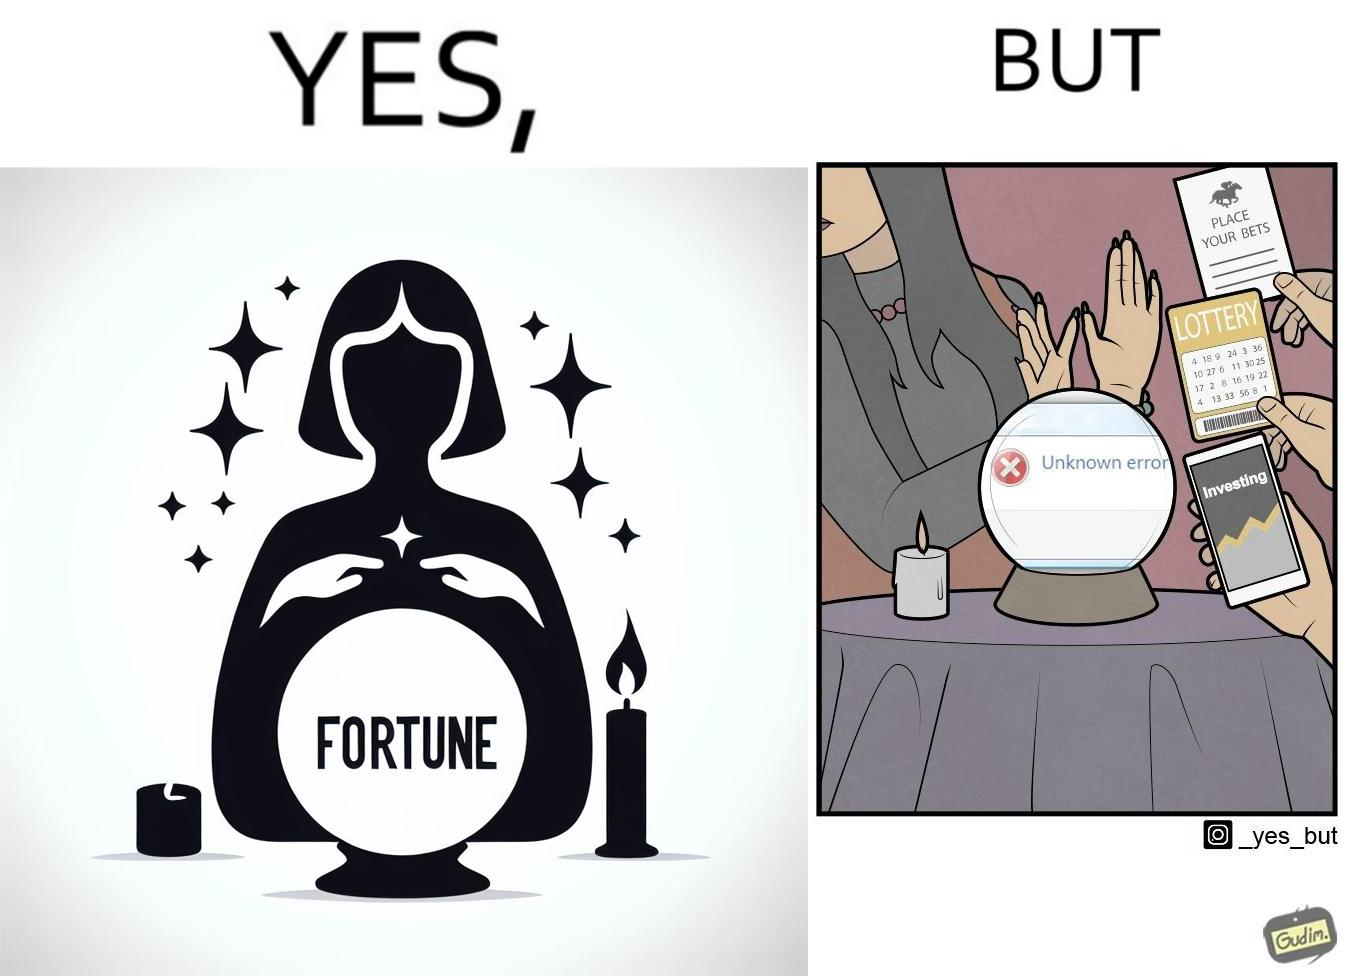What is the satirical meaning behind this image? The people who claim to predict the future either find their predictions unsuccessful or avoid themselves from making claims related to finance, lotteries, and bets. 